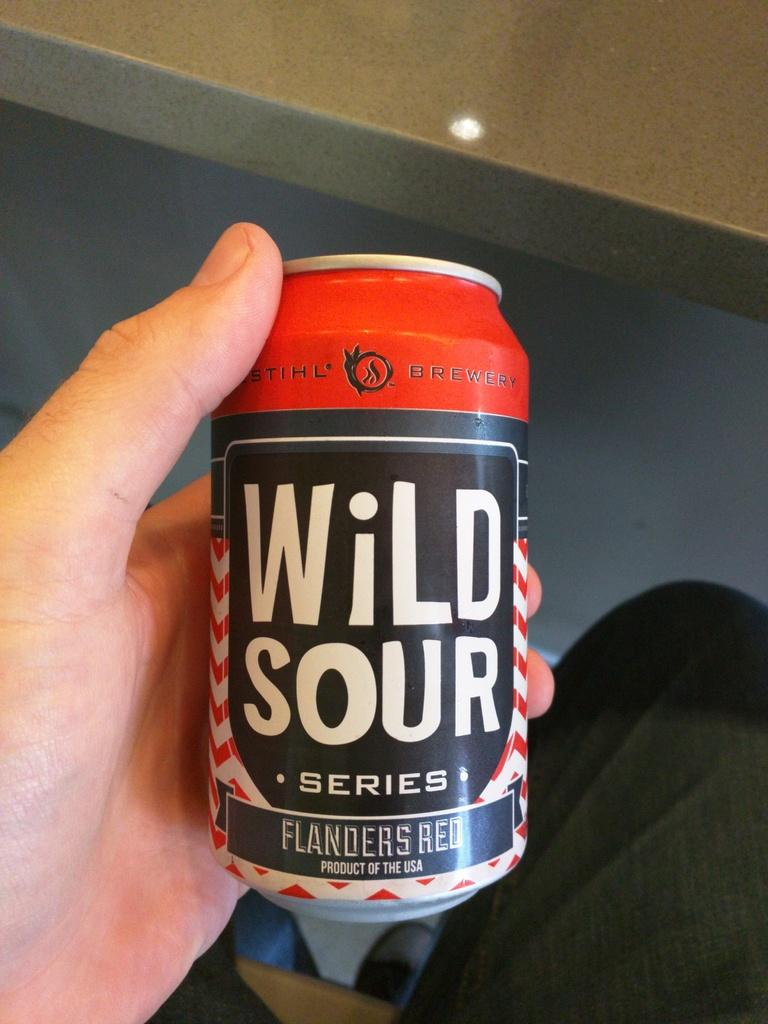<image>
Write a terse but informative summary of the picture. You see a hand holding a can of beer from the Wild Sour series. 